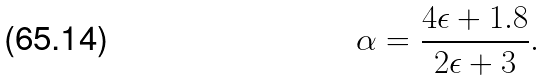Convert formula to latex. <formula><loc_0><loc_0><loc_500><loc_500>\alpha = \frac { 4 \epsilon + 1 . 8 } { 2 \epsilon + 3 } .</formula> 